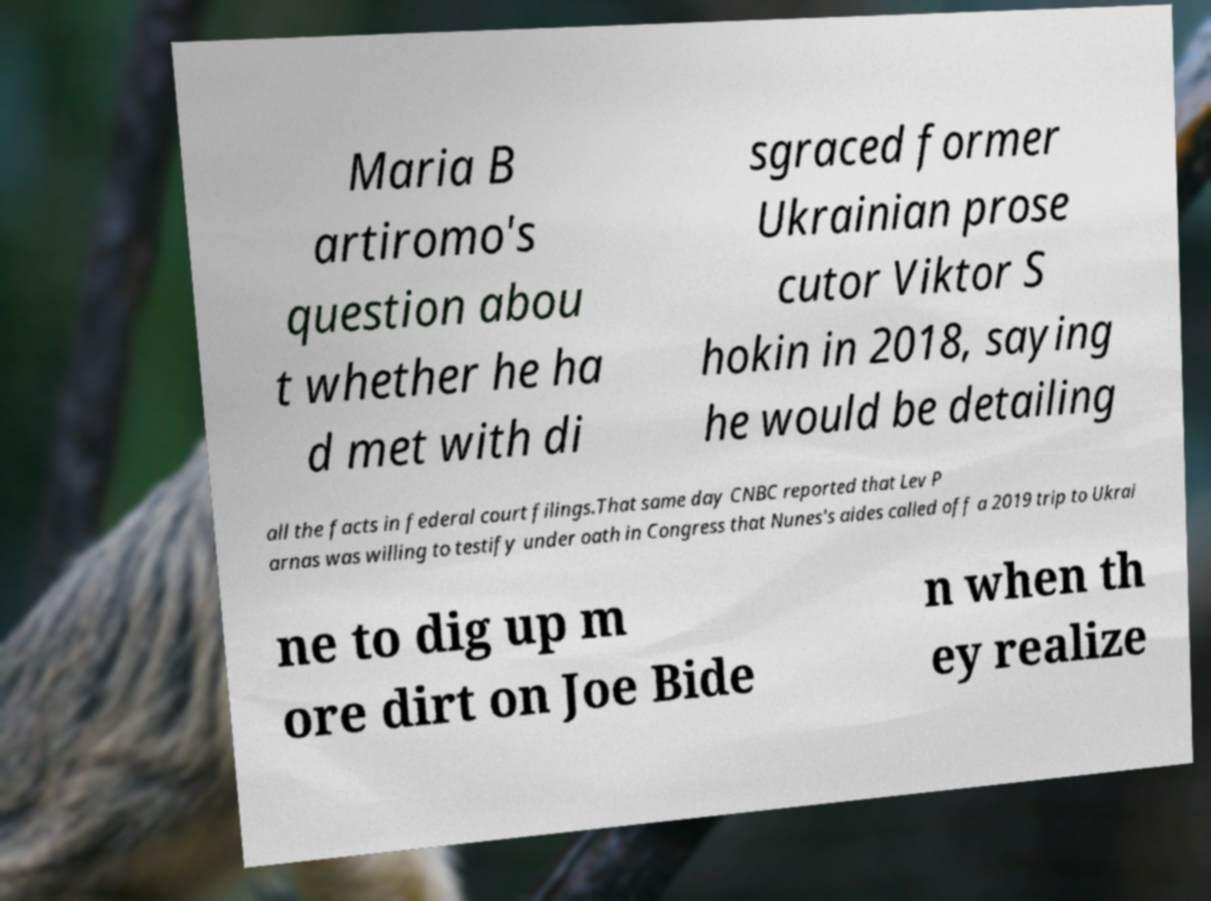Please identify and transcribe the text found in this image. Maria B artiromo's question abou t whether he ha d met with di sgraced former Ukrainian prose cutor Viktor S hokin in 2018, saying he would be detailing all the facts in federal court filings.That same day CNBC reported that Lev P arnas was willing to testify under oath in Congress that Nunes's aides called off a 2019 trip to Ukrai ne to dig up m ore dirt on Joe Bide n when th ey realize 